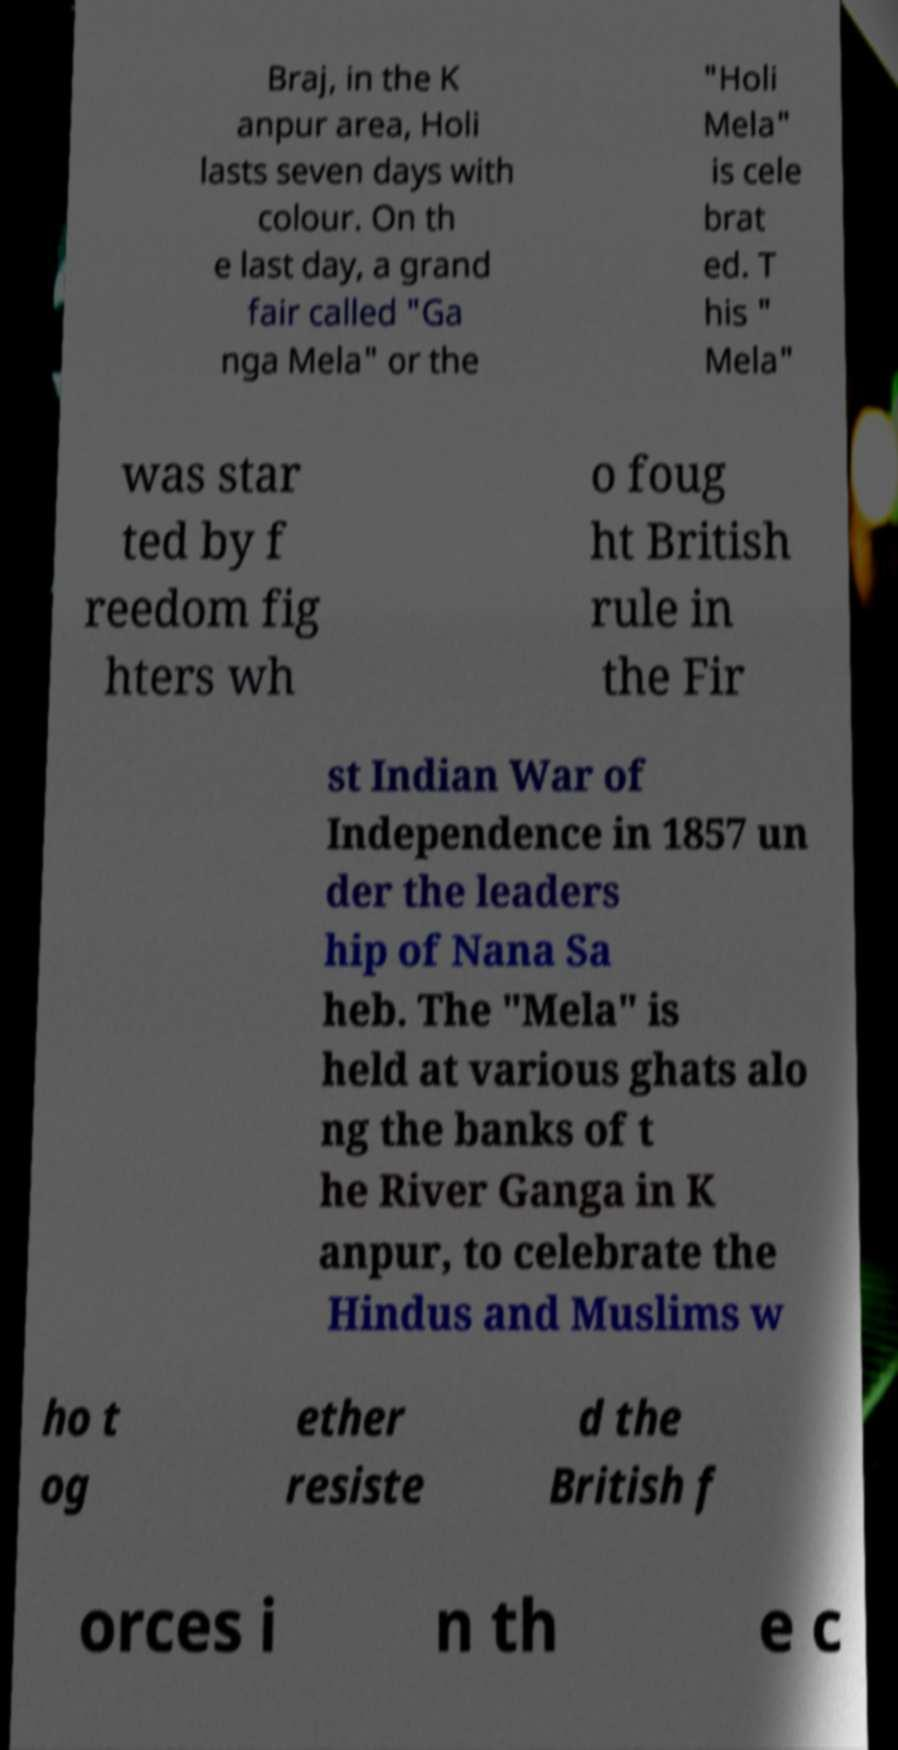Could you assist in decoding the text presented in this image and type it out clearly? Braj, in the K anpur area, Holi lasts seven days with colour. On th e last day, a grand fair called "Ga nga Mela" or the "Holi Mela" is cele brat ed. T his " Mela" was star ted by f reedom fig hters wh o foug ht British rule in the Fir st Indian War of Independence in 1857 un der the leaders hip of Nana Sa heb. The "Mela" is held at various ghats alo ng the banks of t he River Ganga in K anpur, to celebrate the Hindus and Muslims w ho t og ether resiste d the British f orces i n th e c 